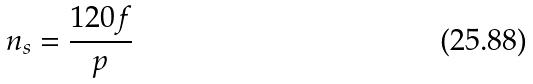Convert formula to latex. <formula><loc_0><loc_0><loc_500><loc_500>n _ { s } = \frac { 1 2 0 f } { p }</formula> 